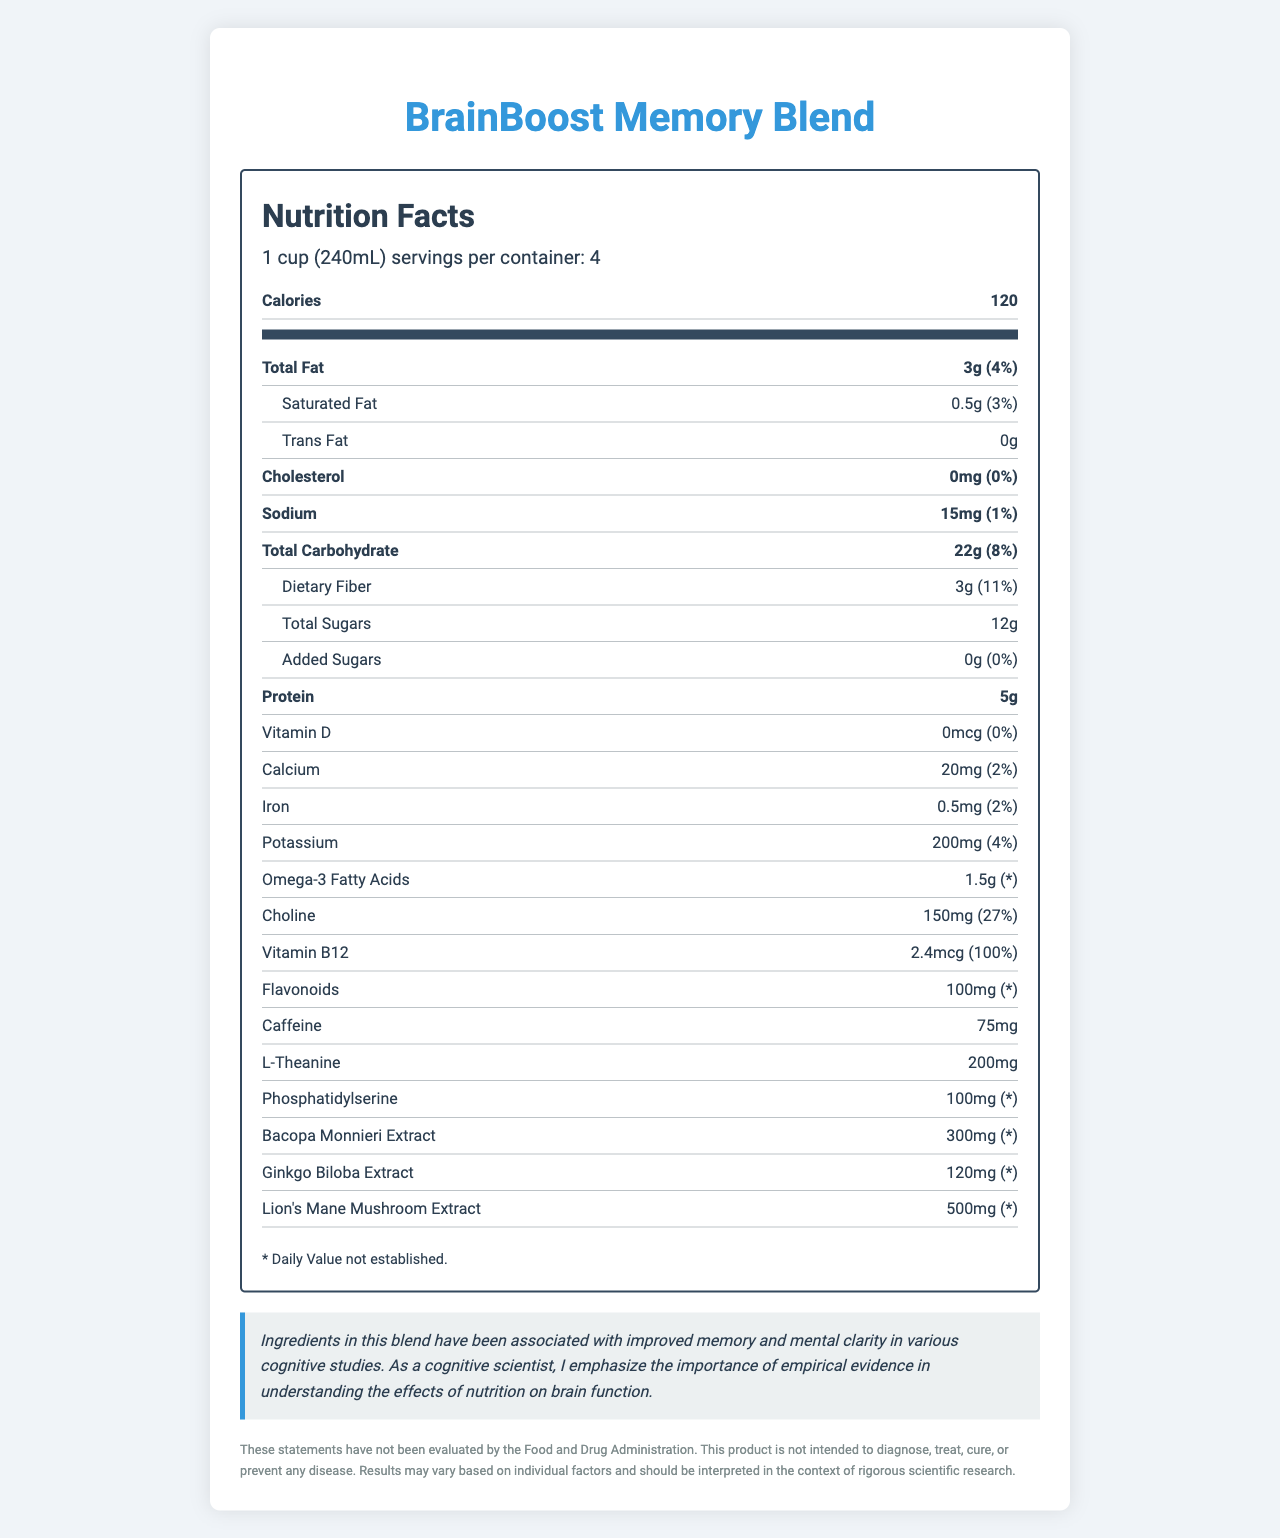What is the serving size of BrainBoost Memory Blend? The document states that the serving size is 1 cup (240mL).
Answer: 1 cup (240mL) How many calories are in one serving of BrainBoost Memory Blend? The document lists the calorie content as 120 per serving.
Answer: 120 What percentage of the daily value of choline does one serving provide? According to the label, one serving provides 27% of the daily value for choline.
Answer: 27% How much protein does one serving contain? The nutrition label specifies that one serving contains 5g of protein.
Answer: 5g What is the total amount of sugars in one serving? The document states that the total amount of sugars in one serving is 12g.
Answer: 12g Which nutrient is present in the highest amount per serving after carbohydrates? After carbohydrates (22g), protein is the next highest at 5g.
Answer: Protein (5g) Which of the following nutrients has no daily value established? A. Omega-3 Fatty Acids B. Vitamin B12 C. Sodium D. Protein The label specifies that the daily value for Omega-3 Fatty Acids is not established, whereas it is established for Vitamin B12, Sodium, and Protein.
Answer: A Which ingredient has the highest amount in the blend: A. Ginkgo Biloba Extract B. L-Theanine C. Lion's Mane Mushroom Extract D. Bacopa Monnieri Extract Lion's Mane Mushroom Extract has the highest amount at 500mg.
Answer: C Does the BrainBoost Memory Blend contain any trans fat? The document clearly states that the trans fat content is 0g.
Answer: No Summarize the cognitive claim related to this product. The document claims that some ingredients in the blend are linked to improved memory and mental clarity based on cognitive studies.
Answer: Ingredients in this blend have been associated with improved memory and mental clarity in various cognitive studies. What percentage of the daily value for fiber does one serving provide? According to the label, one serving provides 11% of the daily value for dietary fiber.
Answer: 11% List all ingredients that have over 100mg per serving. These ingredients each have quantities exceeding 100mg per serving as indicated in the document.
Answer: Choline, L-Theanine, Phosphatidylserine, Bacopa Monnieri Extract, Ginkgo Biloba Extract, Lion's Mane Mushroom Extract Can this product be used to diagnose, treat, cure, or prevent any disease? The disclaimer clearly states that the product is not intended to diagnose, treat, cure, or prevent any disease.
Answer: No What would be the total calorie intake if a person consumes the entire container? Since each serving is 120 calories and there are 4 servings per container, the total calorie intake would be 120 * 4 = 480 calories.
Answer: 480 calories Does the document provide specific empirical evidence to support the cognitive claim? The claim mentions associations made in cognitive studies but does not provide specific empirical evidence within the document.
Answer: No 